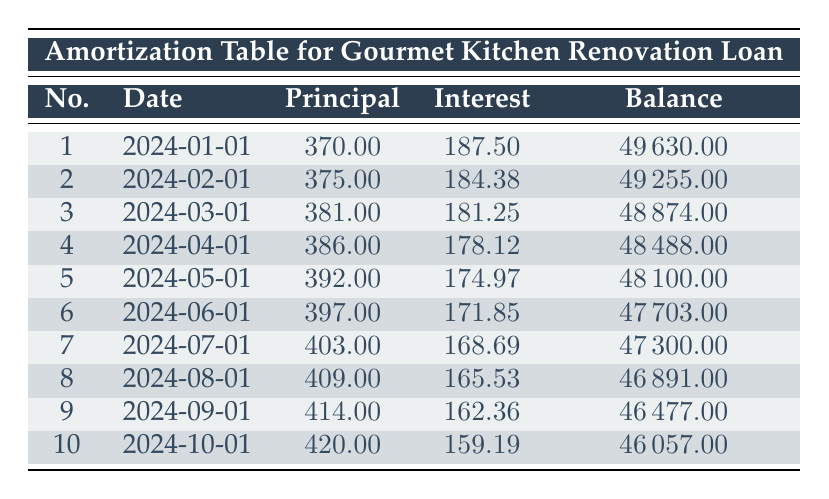What is the principal payment for the first installment? The first installment's row indicates that the principal payment is listed as 370.00.
Answer: 370.00 What is the total interest payment for the first three months? To find the total interest for the first three months, we add the interest payments from the first three rows: 187.50 + 184.38 + 181.25 = 553.13.
Answer: 553.13 Is the interest payment greater than the principal payment in every month? By comparing the interest and principal payments for each month, we see that in all 10 months the interest payment is higher than the principal payment.
Answer: Yes What is the remaining balance after the fifth installment? The remaining balance after the fifth installment is found in the fifth row, which shows a balance of 48100.00.
Answer: 48100.00 What is the average principal payment over the first 10 installments? To calculate the average principal payment, we sum the principal payments from all 10 installments (370.00 + 375.00 + 381.00 + 386.00 + 392.00 + 397.00 + 403.00 + 409.00 + 414.00 + 420.00 = 3,706.00), then divide by 10: 3,706.00 / 10 = 370.60.
Answer: 370.60 What is the overall reduction in the remaining balance from the first payment to the tenth payment? The remaining balance for the first payment is 49630.00, and for the tenth payment, it is 46057.00. The reduction is 49630.00 - 46057.00 = 3573.00.
Answer: 3573.00 What was the principal payment for the 6th installment? The sixth installment's row shows that the principal payment is 397.00.
Answer: 397.00 Was there an increase in the principal payment from each month to the next, at least for the first half of the loan term? Reviewing the principal payments from the first to the fifth installments shows a consistent increase: 370.00, 375.00, 381.00, 386.00, and 392.00. Therefore, the answer is yes.
Answer: Yes What is the total balance reduced after 10 installments? The initial balance was 50000.00, and the remaining balance after 10 payments is 46057.00. The total reduction is 50000.00 - 46057.00 = 3950.00.
Answer: 3950.00 